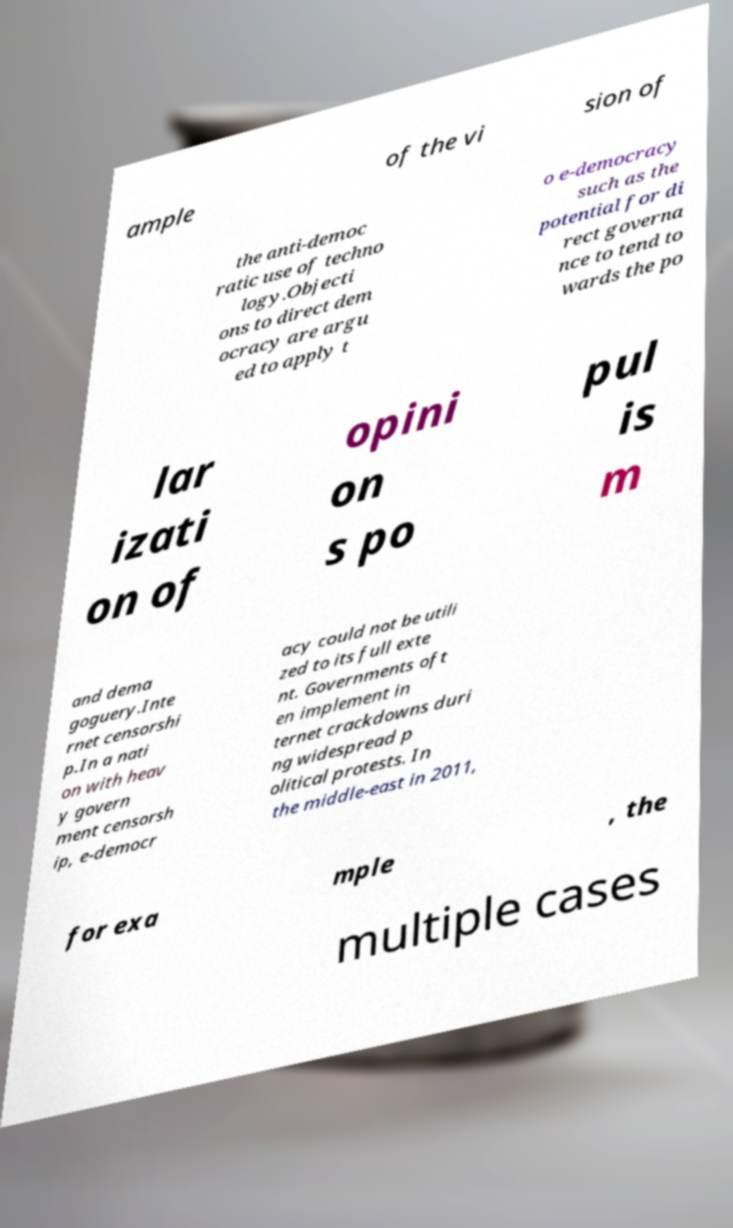What messages or text are displayed in this image? I need them in a readable, typed format. ample of the vi sion of the anti-democ ratic use of techno logy.Objecti ons to direct dem ocracy are argu ed to apply t o e-democracy such as the potential for di rect governa nce to tend to wards the po lar izati on of opini on s po pul is m and dema goguery.Inte rnet censorshi p.In a nati on with heav y govern ment censorsh ip, e-democr acy could not be utili zed to its full exte nt. Governments oft en implement in ternet crackdowns duri ng widespread p olitical protests. In the middle-east in 2011, for exa mple , the multiple cases 